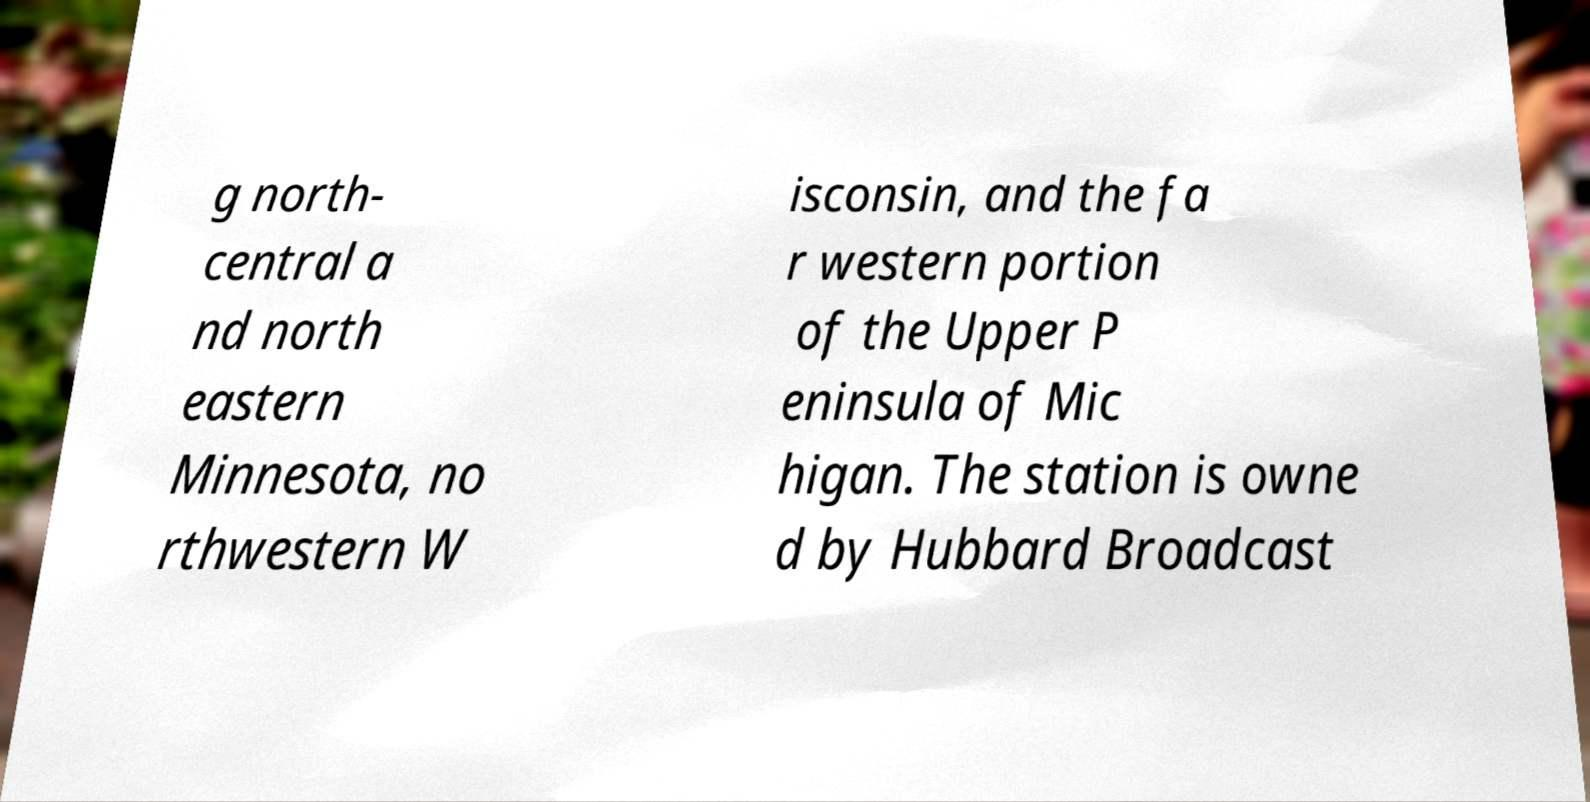For documentation purposes, I need the text within this image transcribed. Could you provide that? g north- central a nd north eastern Minnesota, no rthwestern W isconsin, and the fa r western portion of the Upper P eninsula of Mic higan. The station is owne d by Hubbard Broadcast 